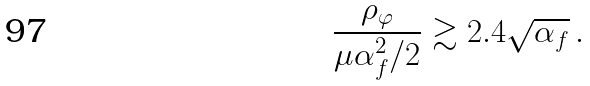<formula> <loc_0><loc_0><loc_500><loc_500>\frac { \rho _ { \varphi } } { \mu \alpha _ { f } ^ { 2 } / 2 } \gtrsim 2 . 4 \sqrt { \alpha _ { f } } \, .</formula> 